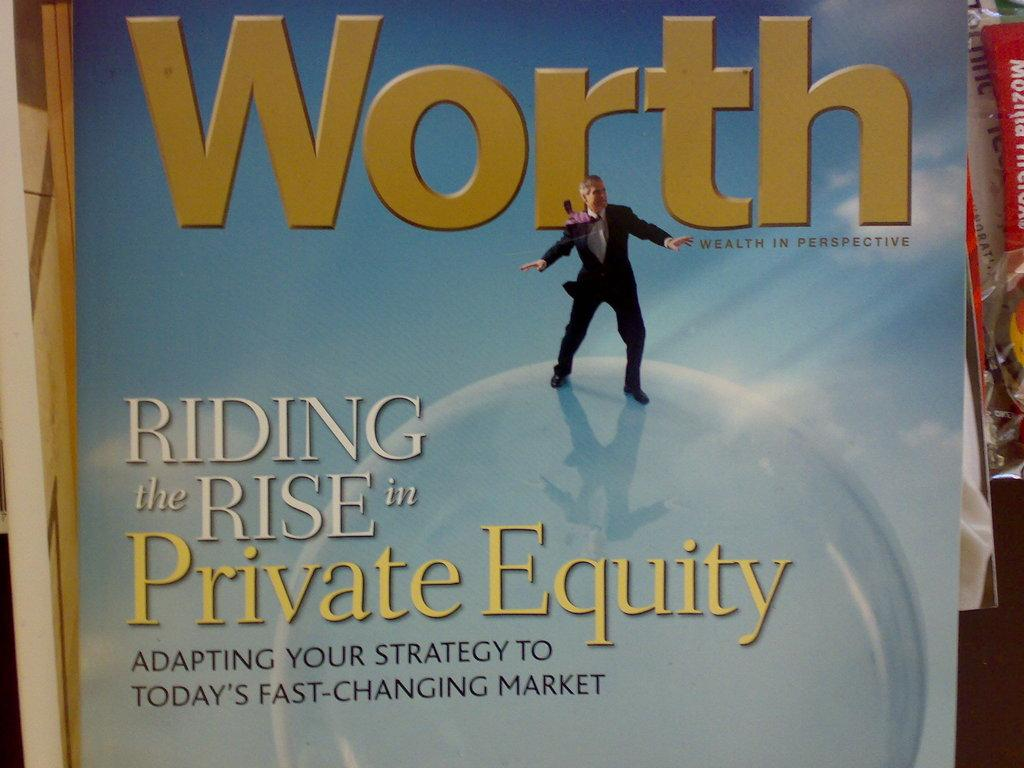<image>
Render a clear and concise summary of the photo. A book or magazine that is titled "Worth." 